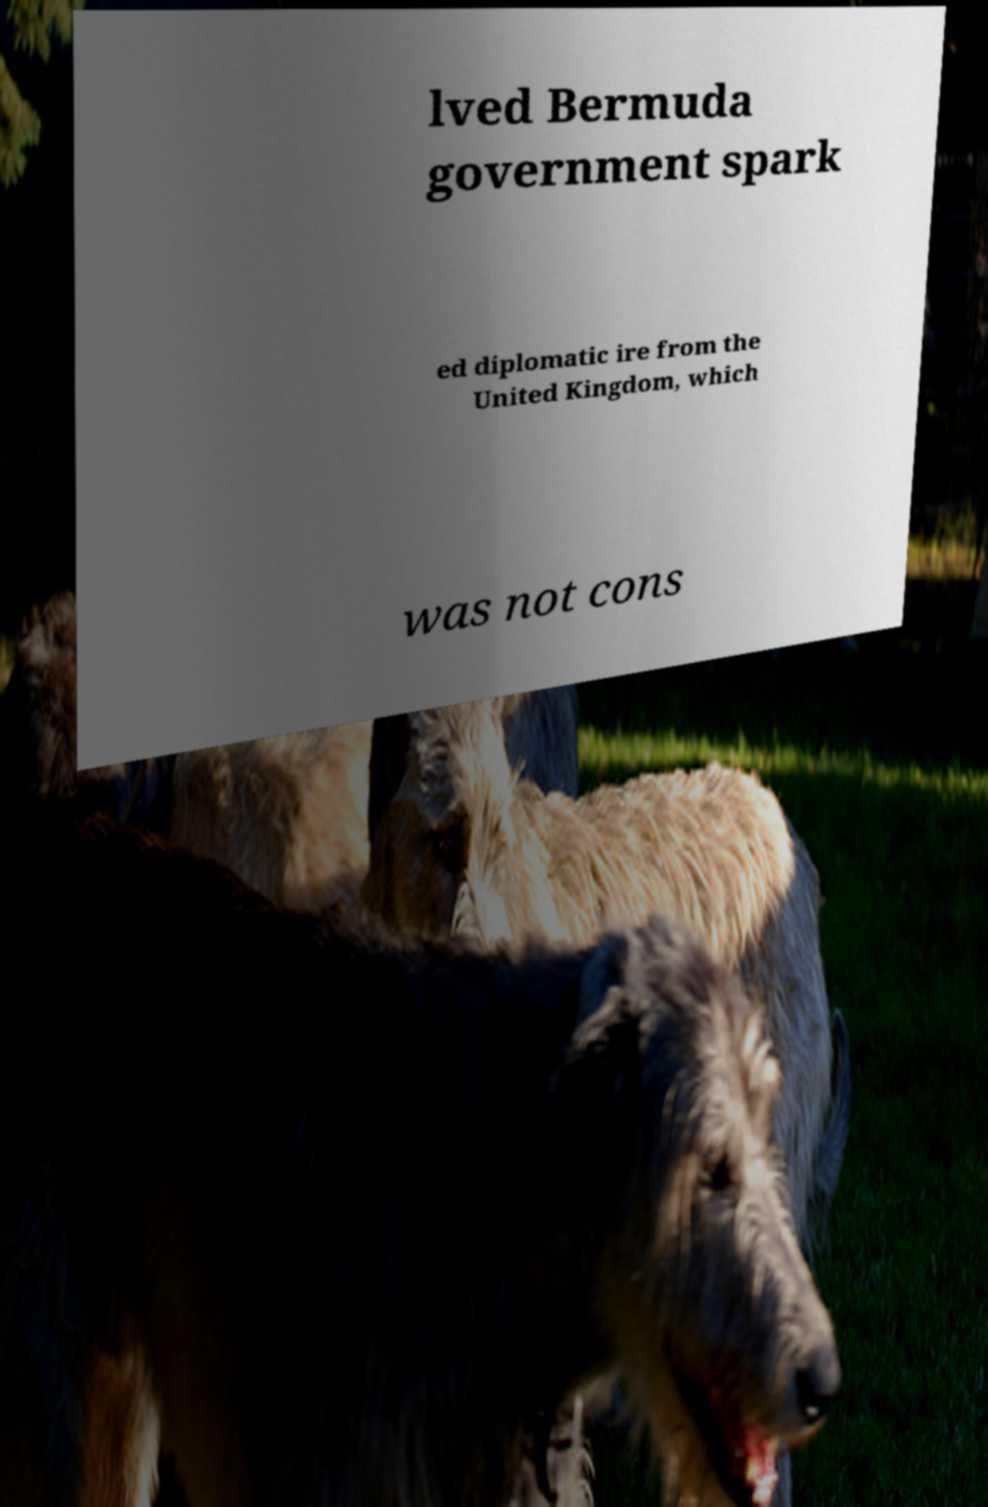Can you read and provide the text displayed in the image?This photo seems to have some interesting text. Can you extract and type it out for me? lved Bermuda government spark ed diplomatic ire from the United Kingdom, which was not cons 